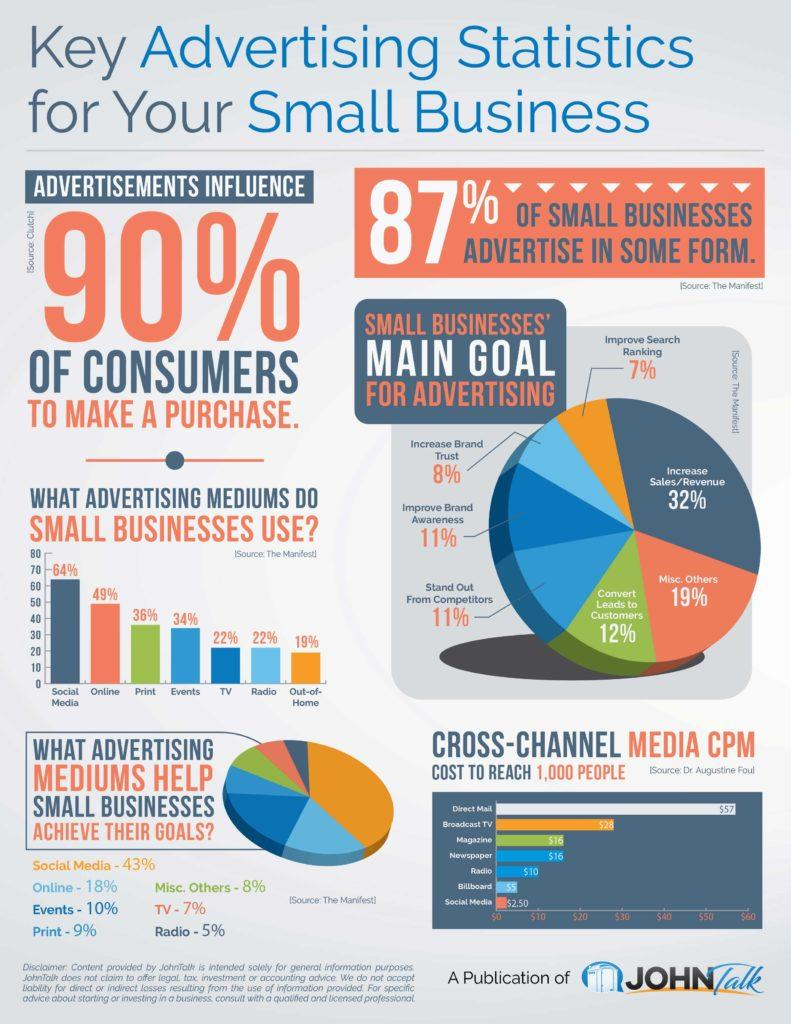Specify some key components in this picture. Social media advertising can help small businesses achieve their goals by up to 43%. TV advertising can be an effective tool for small businesses to achieve their goals, with a reported 7% increase in sales attributed to this form of advertising. According to a study, small businesses are expected to achieve a 32% increase in sales through advertising. According to the data, small businesses can expect to achieve an 8% increase in brand trust through advertising. According to a recent survey, 22% of small businesses use radio advertising. 